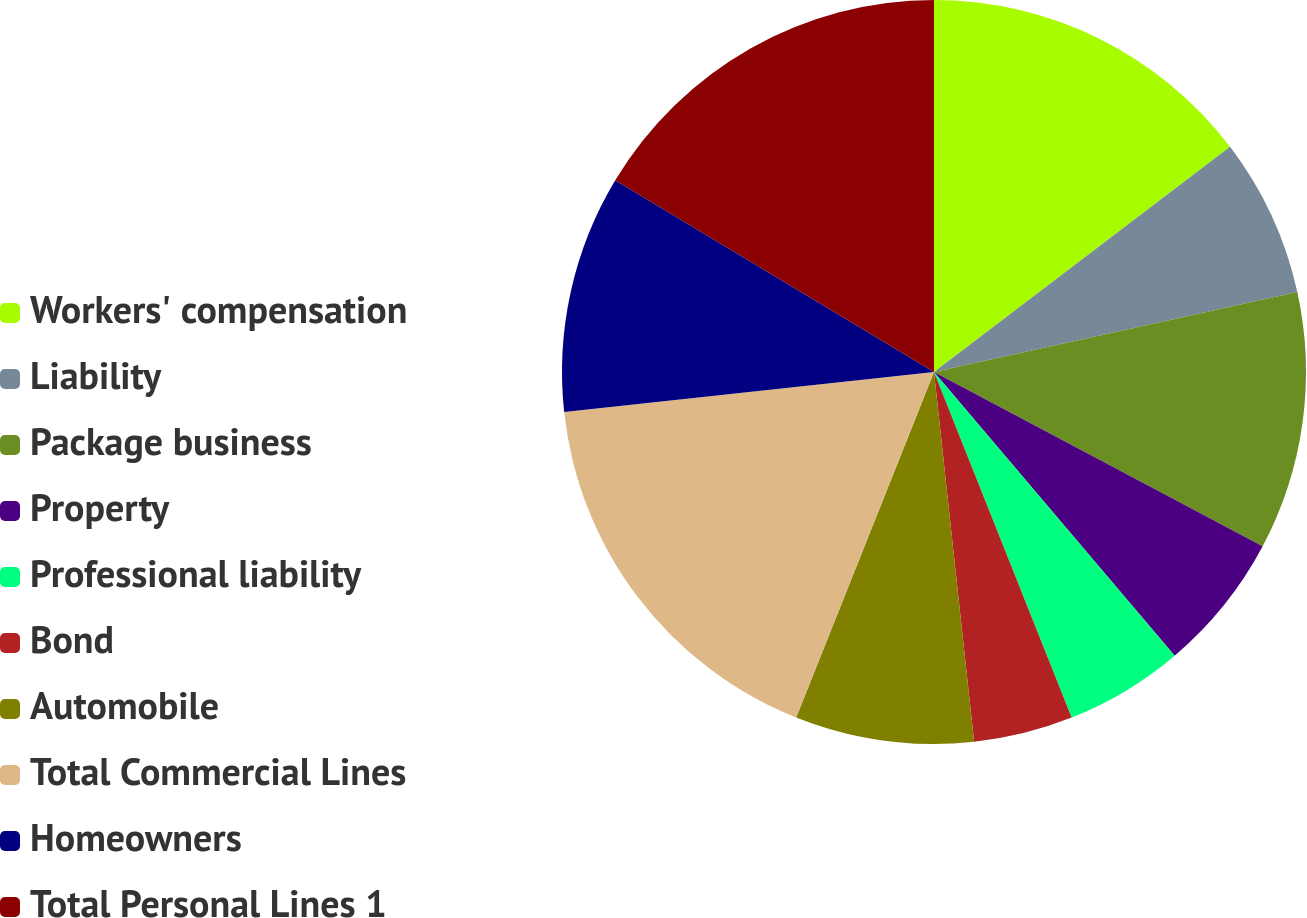Convert chart to OTSL. <chart><loc_0><loc_0><loc_500><loc_500><pie_chart><fcel>Workers' compensation<fcel>Liability<fcel>Package business<fcel>Property<fcel>Professional liability<fcel>Bond<fcel>Automobile<fcel>Total Commercial Lines<fcel>Homeowners<fcel>Total Personal Lines 1<nl><fcel>14.65%<fcel>6.9%<fcel>11.21%<fcel>6.04%<fcel>5.17%<fcel>4.31%<fcel>7.76%<fcel>17.24%<fcel>10.34%<fcel>16.38%<nl></chart> 